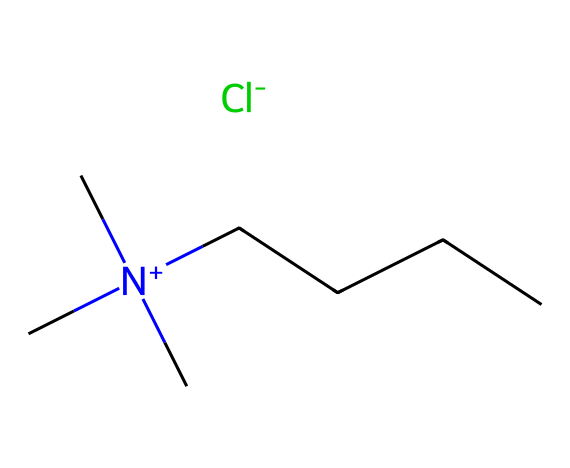What is the cation present in this ionic liquid? The chemical structure contains the group C[N+](C)(C)CCCC, which indicates that the cation is a quaternary ammonium ion.
Answer: quaternary ammonium ion How many carbon atoms are present in the cation? Counting the carbon atoms in the cation part C[N+](C)(C)CCCC shows there are five carbon atoms from the straight chain (CCCC) and three from the three methyl groups (C), leading to a total of eight carbon atoms.
Answer: 8 What is the charge of the nitrogen in this structure? The structure shows a nitrogen atom with a positive charge indicated by [N+], meaning the nitrogen is positively charged.
Answer: positive What is the role of the anion in this ionic liquid? The anion [Cl-] is used to balance the positive charge of the cation, making it neutral overall, acting as a counterion in the ionic liquid.
Answer: counterion Why might this ionic liquid be suitable for preserving ancient Chinese scrolls? Ionic liquids are known for their low volatility and ability to dissolve various organic and inorganic materials, making them useful for stabilization and protection of delicate materials like scrolls.
Answer: low volatility What is the significance of having a room-temperature ionic liquid for preservation? Room-temperature ionic liquids are advantageous because they can be used without heating, which might damage sensitive scrolls, thus maintaining their integrity during the preservation process.
Answer: no heating How does the structure of this ionic liquid influence its solubility properties? The presence of the bulky cation and the chloride anion affects the solubility of the ionic liquid in various solvents, often providing high solubility in polar and nonpolar solvents, which can be tailored for specific applications.
Answer: tailored solubility 